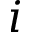Convert formula to latex. <formula><loc_0><loc_0><loc_500><loc_500>i</formula> 